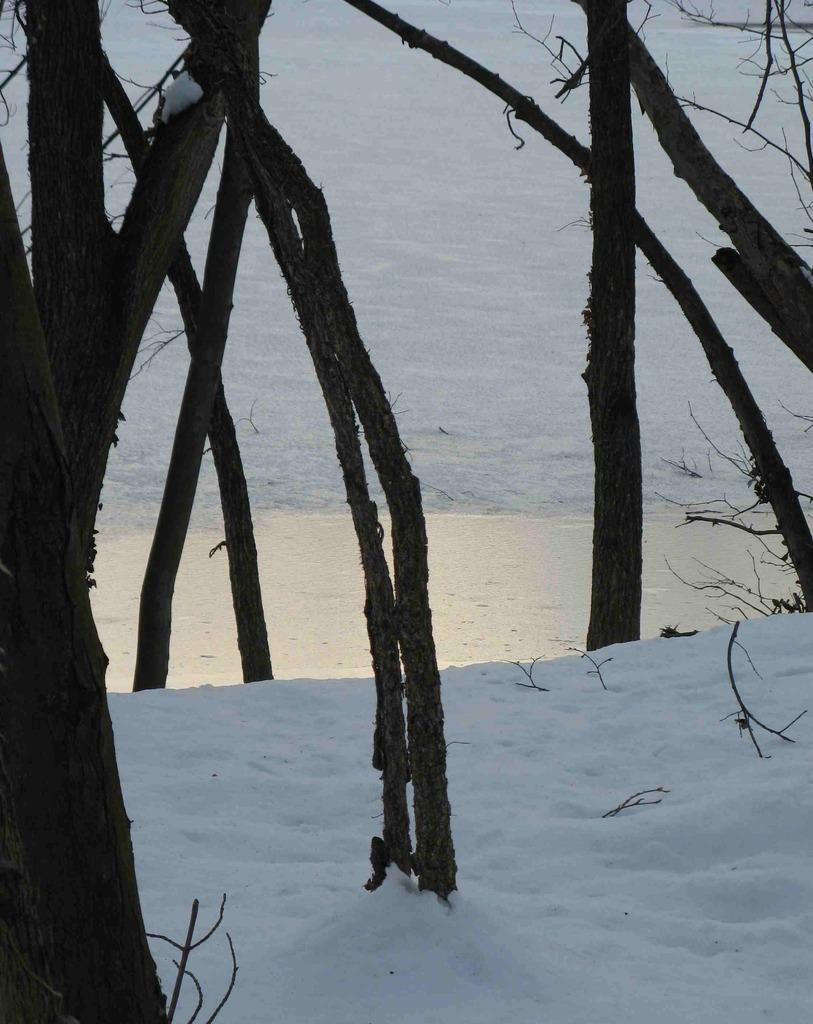What type of natural elements can be seen in the image? The image contains the barks of the trees. What is visible at the bottom of the image? There is snow at the bottom of the image. What type of dinner is being served in the image? There is no dinner present in the image; it features the barks of the trees and snow. What type of care is being provided to the crib in the image? There is no crib present in the image. 